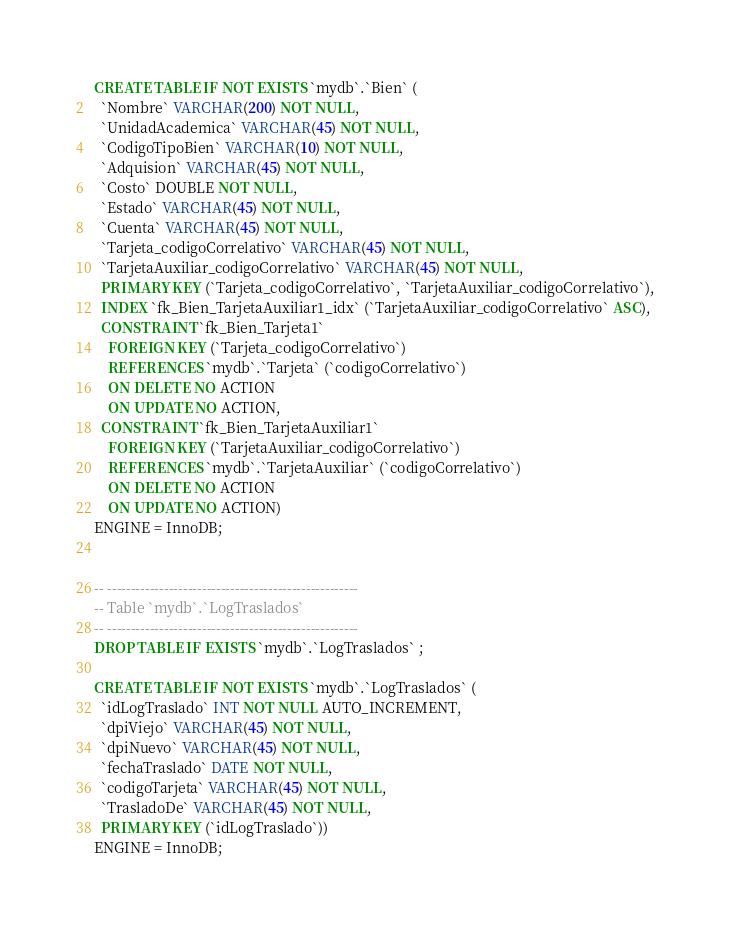<code> <loc_0><loc_0><loc_500><loc_500><_SQL_>
CREATE TABLE IF NOT EXISTS `mydb`.`Bien` (
  `Nombre` VARCHAR(200) NOT NULL,
  `UnidadAcademica` VARCHAR(45) NOT NULL,
  `CodigoTipoBien` VARCHAR(10) NOT NULL,
  `Adquision` VARCHAR(45) NOT NULL,
  `Costo` DOUBLE NOT NULL,
  `Estado` VARCHAR(45) NOT NULL,
  `Cuenta` VARCHAR(45) NOT NULL,
  `Tarjeta_codigoCorrelativo` VARCHAR(45) NOT NULL,
  `TarjetaAuxiliar_codigoCorrelativo` VARCHAR(45) NOT NULL,
  PRIMARY KEY (`Tarjeta_codigoCorrelativo`, `TarjetaAuxiliar_codigoCorrelativo`),
  INDEX `fk_Bien_TarjetaAuxiliar1_idx` (`TarjetaAuxiliar_codigoCorrelativo` ASC),
  CONSTRAINT `fk_Bien_Tarjeta1`
    FOREIGN KEY (`Tarjeta_codigoCorrelativo`)
    REFERENCES `mydb`.`Tarjeta` (`codigoCorrelativo`)
    ON DELETE NO ACTION
    ON UPDATE NO ACTION,
  CONSTRAINT `fk_Bien_TarjetaAuxiliar1`
    FOREIGN KEY (`TarjetaAuxiliar_codigoCorrelativo`)
    REFERENCES `mydb`.`TarjetaAuxiliar` (`codigoCorrelativo`)
    ON DELETE NO ACTION
    ON UPDATE NO ACTION)
ENGINE = InnoDB;


-- -----------------------------------------------------
-- Table `mydb`.`LogTraslados`
-- -----------------------------------------------------
DROP TABLE IF EXISTS `mydb`.`LogTraslados` ;

CREATE TABLE IF NOT EXISTS `mydb`.`LogTraslados` (
  `idLogTraslado` INT NOT NULL AUTO_INCREMENT,
  `dpiViejo` VARCHAR(45) NOT NULL,
  `dpiNuevo` VARCHAR(45) NOT NULL,
  `fechaTraslado` DATE NOT NULL,
  `codigoTarjeta` VARCHAR(45) NOT NULL,
  `TrasladoDe` VARCHAR(45) NOT NULL,
  PRIMARY KEY (`idLogTraslado`))
ENGINE = InnoDB;
</code> 